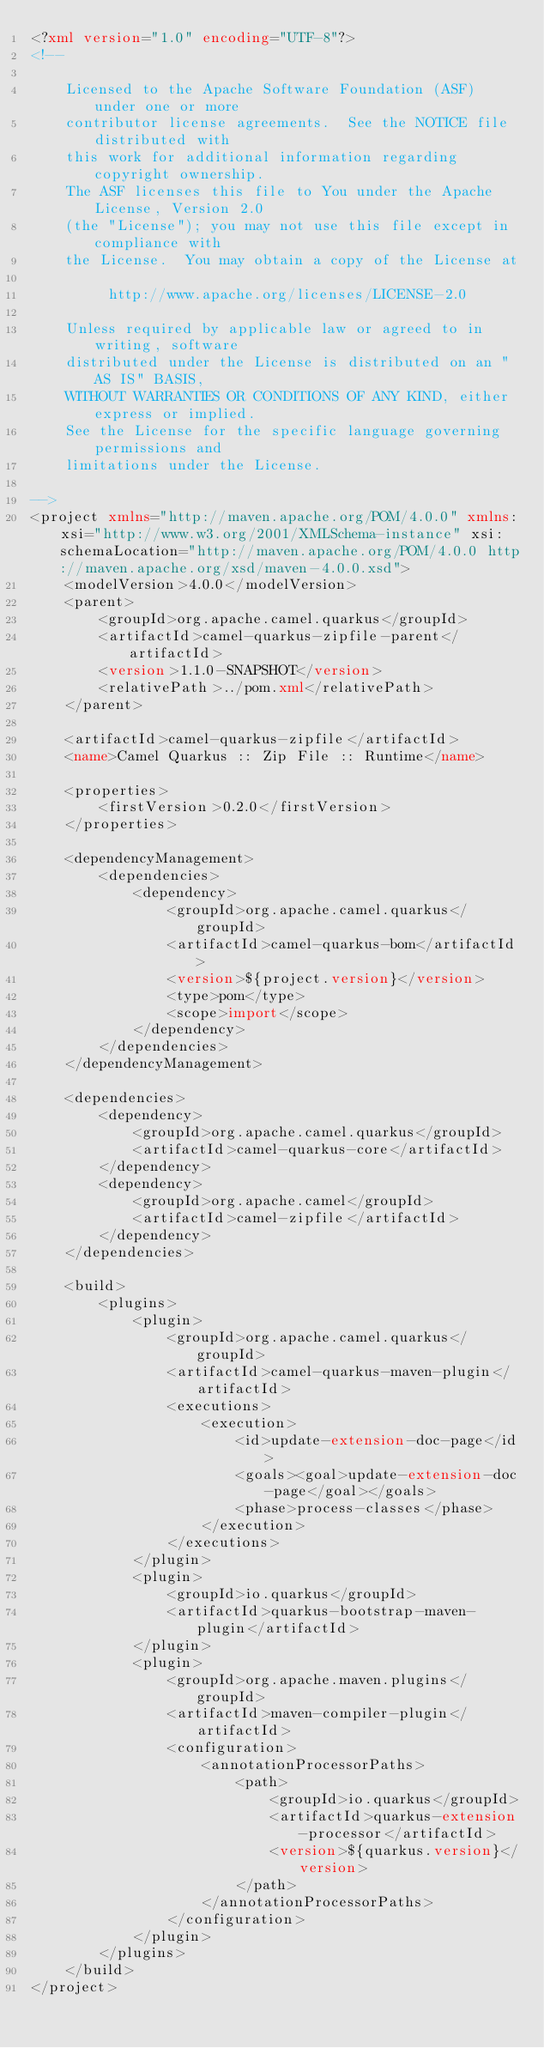<code> <loc_0><loc_0><loc_500><loc_500><_XML_><?xml version="1.0" encoding="UTF-8"?>
<!--

    Licensed to the Apache Software Foundation (ASF) under one or more
    contributor license agreements.  See the NOTICE file distributed with
    this work for additional information regarding copyright ownership.
    The ASF licenses this file to You under the Apache License, Version 2.0
    (the "License"); you may not use this file except in compliance with
    the License.  You may obtain a copy of the License at

         http://www.apache.org/licenses/LICENSE-2.0

    Unless required by applicable law or agreed to in writing, software
    distributed under the License is distributed on an "AS IS" BASIS,
    WITHOUT WARRANTIES OR CONDITIONS OF ANY KIND, either express or implied.
    See the License for the specific language governing permissions and
    limitations under the License.

-->
<project xmlns="http://maven.apache.org/POM/4.0.0" xmlns:xsi="http://www.w3.org/2001/XMLSchema-instance" xsi:schemaLocation="http://maven.apache.org/POM/4.0.0 http://maven.apache.org/xsd/maven-4.0.0.xsd">
    <modelVersion>4.0.0</modelVersion>
    <parent>
        <groupId>org.apache.camel.quarkus</groupId>
        <artifactId>camel-quarkus-zipfile-parent</artifactId>
        <version>1.1.0-SNAPSHOT</version>
        <relativePath>../pom.xml</relativePath>
    </parent>

    <artifactId>camel-quarkus-zipfile</artifactId>
    <name>Camel Quarkus :: Zip File :: Runtime</name>

    <properties>
        <firstVersion>0.2.0</firstVersion>
    </properties>

    <dependencyManagement>
        <dependencies>
            <dependency>
                <groupId>org.apache.camel.quarkus</groupId>
                <artifactId>camel-quarkus-bom</artifactId>
                <version>${project.version}</version>
                <type>pom</type>
                <scope>import</scope>
            </dependency>
        </dependencies>
    </dependencyManagement>

    <dependencies>
        <dependency>
            <groupId>org.apache.camel.quarkus</groupId>
            <artifactId>camel-quarkus-core</artifactId>
        </dependency>
        <dependency>
            <groupId>org.apache.camel</groupId>
            <artifactId>camel-zipfile</artifactId>
        </dependency>
    </dependencies>

    <build>
        <plugins>
            <plugin>
                <groupId>org.apache.camel.quarkus</groupId>
                <artifactId>camel-quarkus-maven-plugin</artifactId>
                <executions>
                    <execution>
                        <id>update-extension-doc-page</id>
                        <goals><goal>update-extension-doc-page</goal></goals>
                        <phase>process-classes</phase>
                    </execution>
                </executions>
            </plugin>
            <plugin>
                <groupId>io.quarkus</groupId>
                <artifactId>quarkus-bootstrap-maven-plugin</artifactId>
            </plugin>
            <plugin>
                <groupId>org.apache.maven.plugins</groupId>
                <artifactId>maven-compiler-plugin</artifactId>
                <configuration>
                    <annotationProcessorPaths>
                        <path>
                            <groupId>io.quarkus</groupId>
                            <artifactId>quarkus-extension-processor</artifactId>
                            <version>${quarkus.version}</version>
                        </path>
                    </annotationProcessorPaths>
                </configuration>
            </plugin>
        </plugins>
    </build>
</project>
</code> 